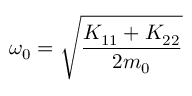Convert formula to latex. <formula><loc_0><loc_0><loc_500><loc_500>\omega _ { 0 } = \sqrt { \frac { K _ { 1 1 } + K _ { 2 2 } } { 2 m _ { 0 } } }</formula> 